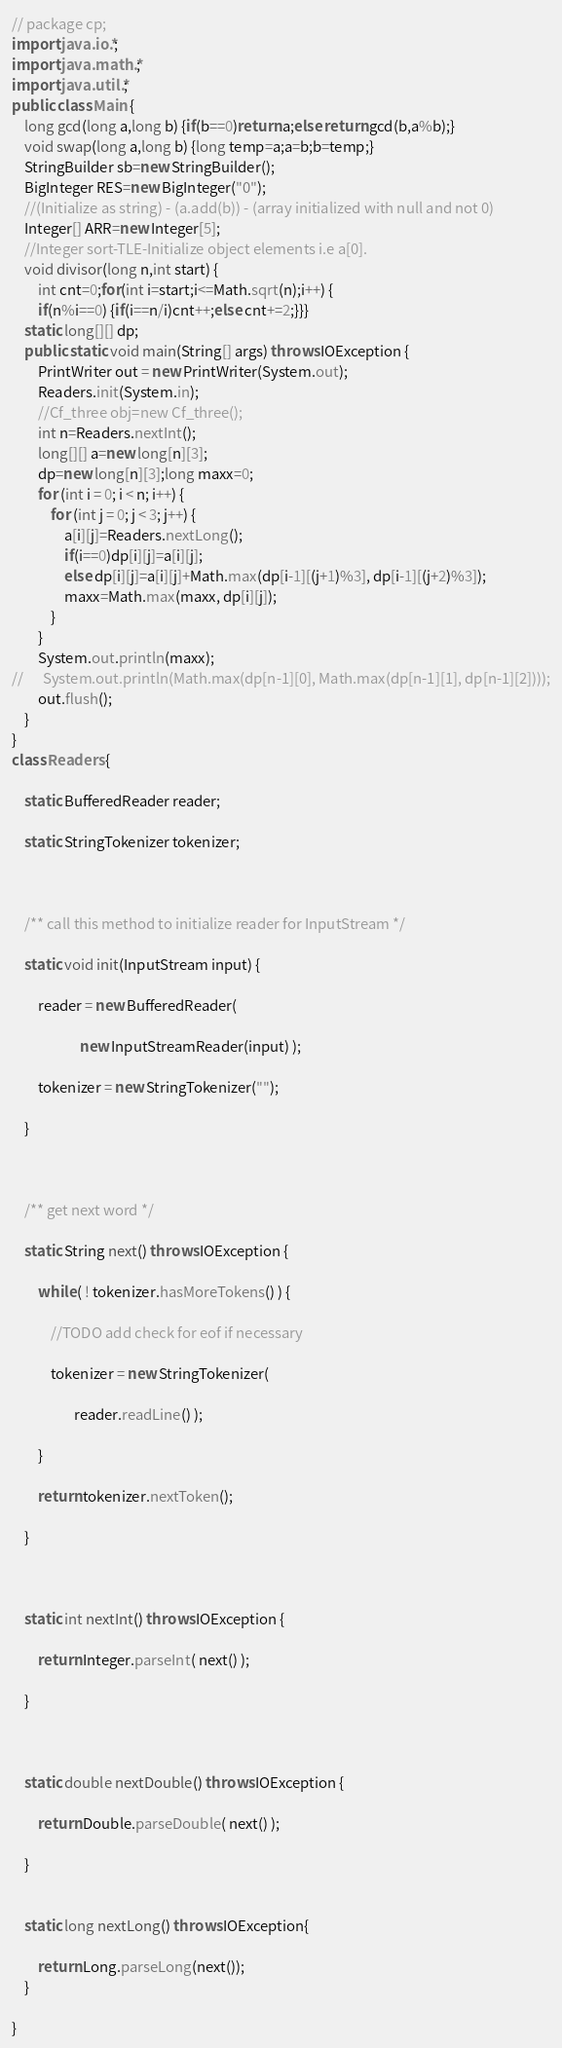<code> <loc_0><loc_0><loc_500><loc_500><_Java_>// package cp;
import java.io.*;
import java.math.*;
import java.util.*;
public class Main {
	long gcd(long a,long b) {if(b==0)return a;else return gcd(b,a%b);}
	void swap(long a,long b) {long temp=a;a=b;b=temp;}
	StringBuilder sb=new StringBuilder();
	BigInteger RES=new BigInteger("0");
	//(Initialize as string) - (a.add(b)) - (array initialized with null and not 0)
	Integer[] ARR=new Integer[5];
	//Integer sort-TLE-Initialize object elements i.e a[0].
	void divisor(long n,int start) {
		int cnt=0;for(int i=start;i<=Math.sqrt(n);i++) {
		if(n%i==0) {if(i==n/i)cnt++;else cnt+=2;}}}
	static long[][] dp;
	public static void main(String[] args) throws IOException {	
		PrintWriter out = new PrintWriter(System.out);
		Readers.init(System.in);
		//Cf_three obj=new Cf_three();
		int n=Readers.nextInt();
		long[][] a=new long[n][3];
		dp=new long[n][3];long maxx=0;
		for (int i = 0; i < n; i++) {
			for (int j = 0; j < 3; j++) {
				a[i][j]=Readers.nextLong();
				if(i==0)dp[i][j]=a[i][j];
				else dp[i][j]=a[i][j]+Math.max(dp[i-1][(j+1)%3], dp[i-1][(j+2)%3]);
				maxx=Math.max(maxx, dp[i][j]);
			}
		}
		System.out.println(maxx);
//		System.out.println(Math.max(dp[n-1][0], Math.max(dp[n-1][1], dp[n-1][2])));
		out.flush();
	}
}
class Readers {
 
    static BufferedReader reader;
 
    static StringTokenizer tokenizer;
 
 
 
    /** call this method to initialize reader for InputStream */
 
    static void init(InputStream input) {
 
        reader = new BufferedReader(
 
                     new InputStreamReader(input) );
 
        tokenizer = new StringTokenizer("");
 
    }
 
 
 
    /** get next word */
 
    static String next() throws IOException {
 
        while ( ! tokenizer.hasMoreTokens() ) {
 
            //TODO add check for eof if necessary
 
            tokenizer = new StringTokenizer(
 
                   reader.readLine() );
 
        }
 
        return tokenizer.nextToken();
 
    }
 
 
 
    static int nextInt() throws IOException {
 
        return Integer.parseInt( next() );
 
    }
 
	
 
    static double nextDouble() throws IOException {
 
        return Double.parseDouble( next() );
 
    }
    
    
    static long nextLong() throws IOException{
    	
		return Long.parseLong(next());
	}
 
}</code> 